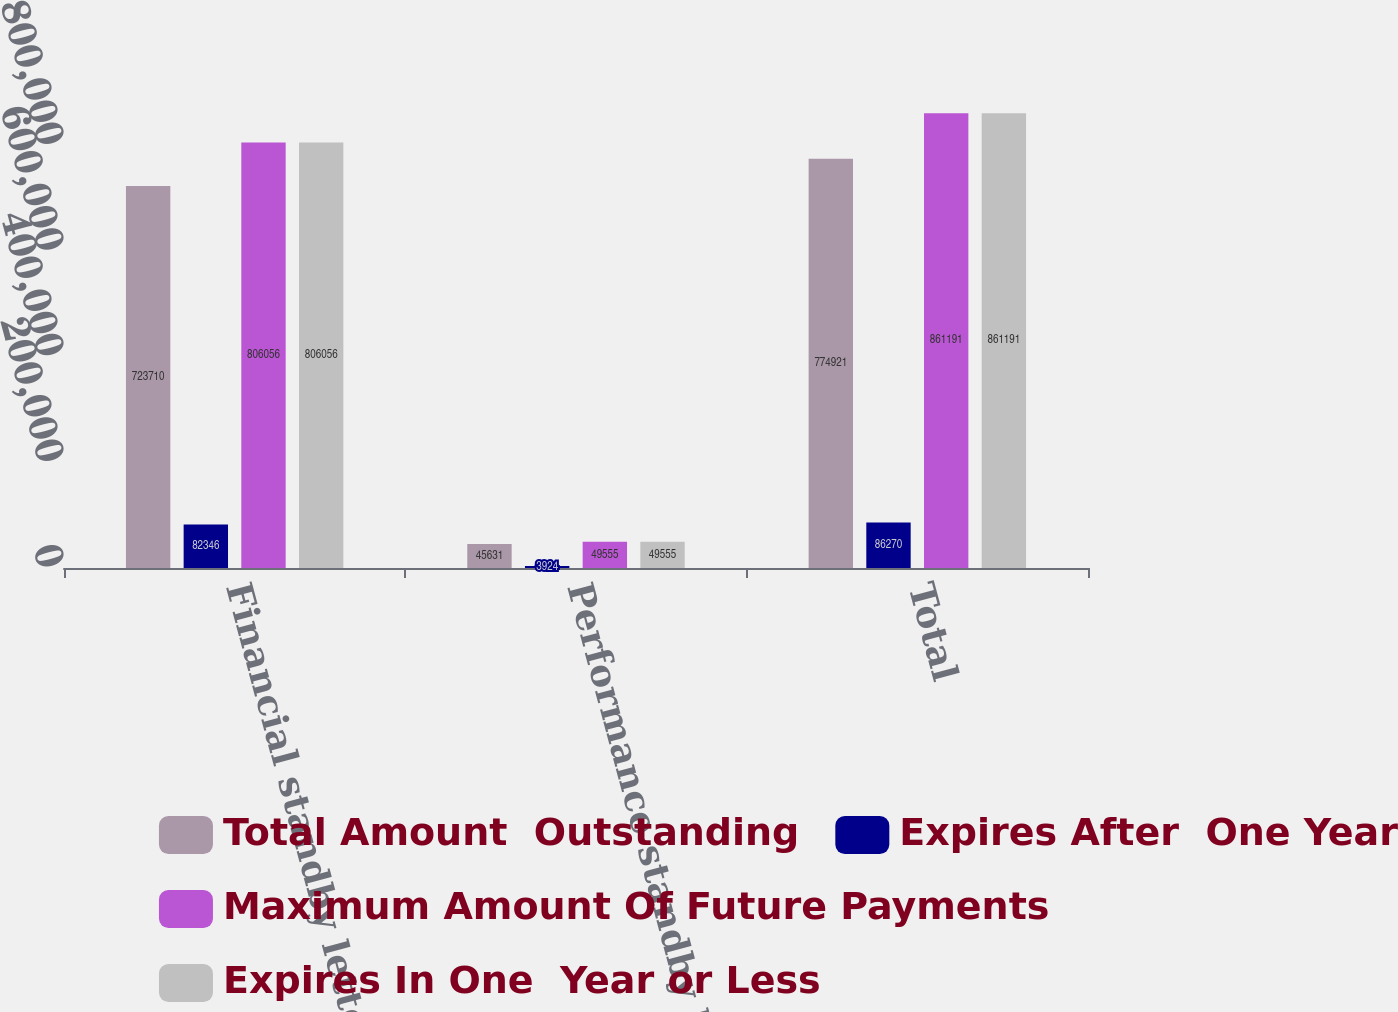Convert chart to OTSL. <chart><loc_0><loc_0><loc_500><loc_500><stacked_bar_chart><ecel><fcel>Financial standby letters of<fcel>Performance standby letters of<fcel>Total<nl><fcel>Total Amount  Outstanding<fcel>723710<fcel>45631<fcel>774921<nl><fcel>Expires After  One Year<fcel>82346<fcel>3924<fcel>86270<nl><fcel>Maximum Amount Of Future Payments<fcel>806056<fcel>49555<fcel>861191<nl><fcel>Expires In One  Year or Less<fcel>806056<fcel>49555<fcel>861191<nl></chart> 